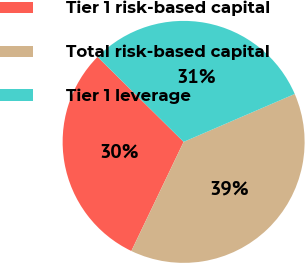Convert chart. <chart><loc_0><loc_0><loc_500><loc_500><pie_chart><fcel>Tier 1 risk-based capital<fcel>Total risk-based capital<fcel>Tier 1 leverage<nl><fcel>30.29%<fcel>38.59%<fcel>31.12%<nl></chart> 